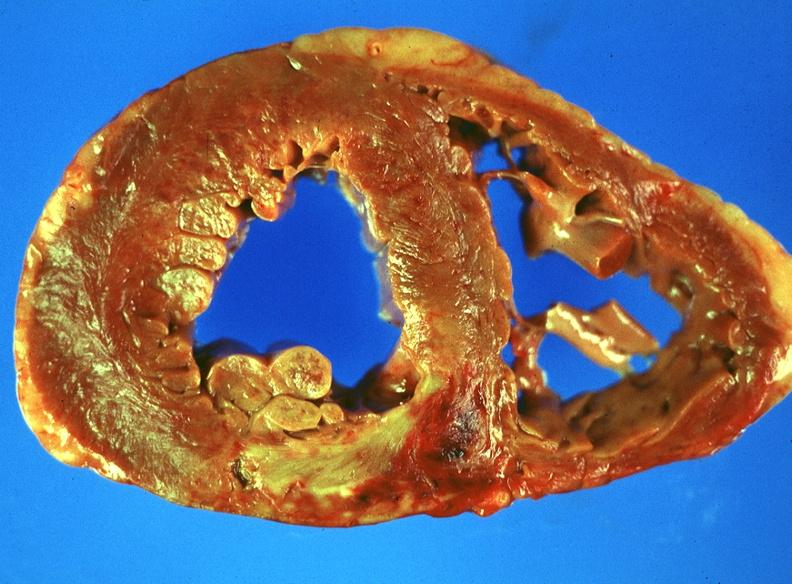what does this image show?
Answer the question using a single word or phrase. Acute myocardial infarction 